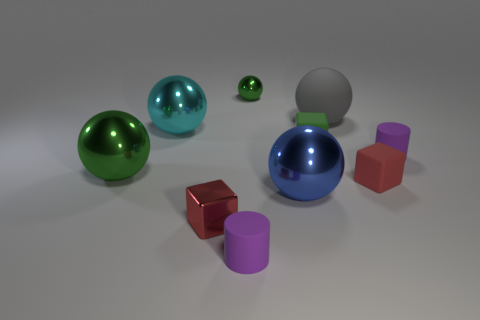There is a small rubber thing that is the same color as the metal cube; what shape is it?
Offer a very short reply. Cube. What is the shape of the green object that is the same material as the big green sphere?
Ensure brevity in your answer.  Sphere. Is there anything else of the same color as the small shiny ball?
Your response must be concise. Yes. There is a small green thing that is the same shape as the cyan thing; what is it made of?
Give a very brief answer. Metal. What number of other things are the same size as the green rubber object?
Offer a terse response. 5. What size is the object that is the same color as the tiny shiny cube?
Your answer should be compact. Small. There is a blue thing to the right of the small green sphere; is it the same shape as the cyan thing?
Make the answer very short. Yes. How many other objects are the same shape as the blue thing?
Give a very brief answer. 4. There is a big thing that is in front of the red rubber block; what is its shape?
Your answer should be very brief. Sphere. Are there any large blue things made of the same material as the large gray thing?
Provide a succinct answer. No. 